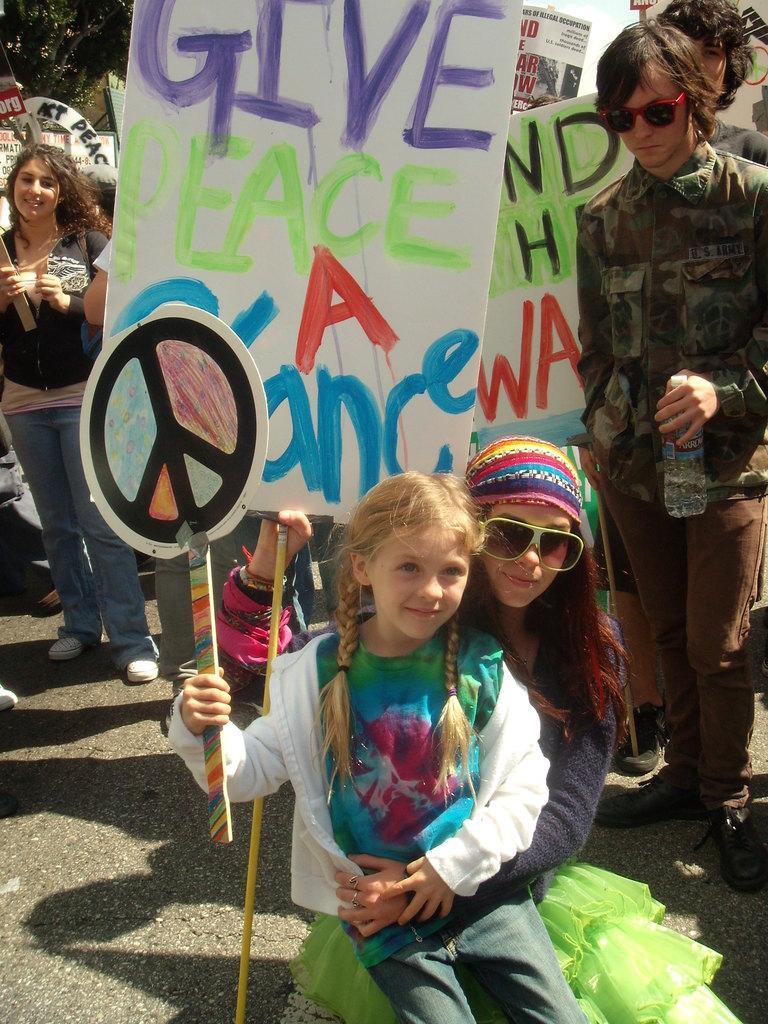Can you describe this image briefly? In this image at front there are two persons sitting by holding the banners. At the back side there are few people standing by holding the banners. Behind them there are trees. 